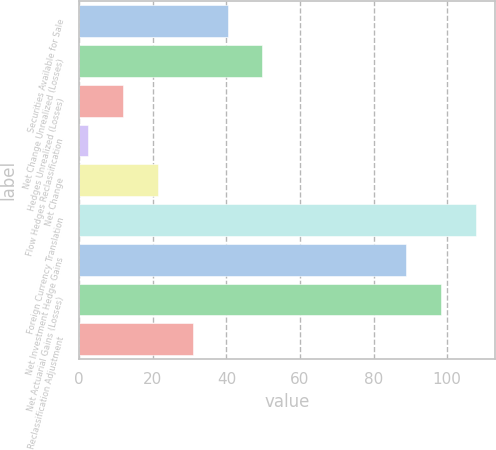Convert chart to OTSL. <chart><loc_0><loc_0><loc_500><loc_500><bar_chart><fcel>Securities Available for Sale<fcel>Net Change Unrealized (Losses)<fcel>Hedges Unrealized (Losses)<fcel>Flow Hedges Reclassification<fcel>Net Change<fcel>Foreign Currency Translation<fcel>Net Investment Hedge Gains<fcel>Net Actuarial Gains (Losses)<fcel>Reclassification Adjustment<nl><fcel>40.3<fcel>49.75<fcel>11.95<fcel>2.5<fcel>21.4<fcel>107.7<fcel>88.8<fcel>98.25<fcel>30.85<nl></chart> 